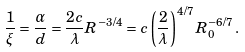Convert formula to latex. <formula><loc_0><loc_0><loc_500><loc_500>\frac { 1 } { \xi } = \frac { \alpha } { d } = \frac { 2 c } { \lambda } R ^ { - 3 / 4 } = c \left ( \frac { 2 } { \lambda } \right ) ^ { 4 / 7 } R _ { 0 } ^ { - 6 / 7 } \, .</formula> 